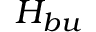<formula> <loc_0><loc_0><loc_500><loc_500>H _ { b u }</formula> 